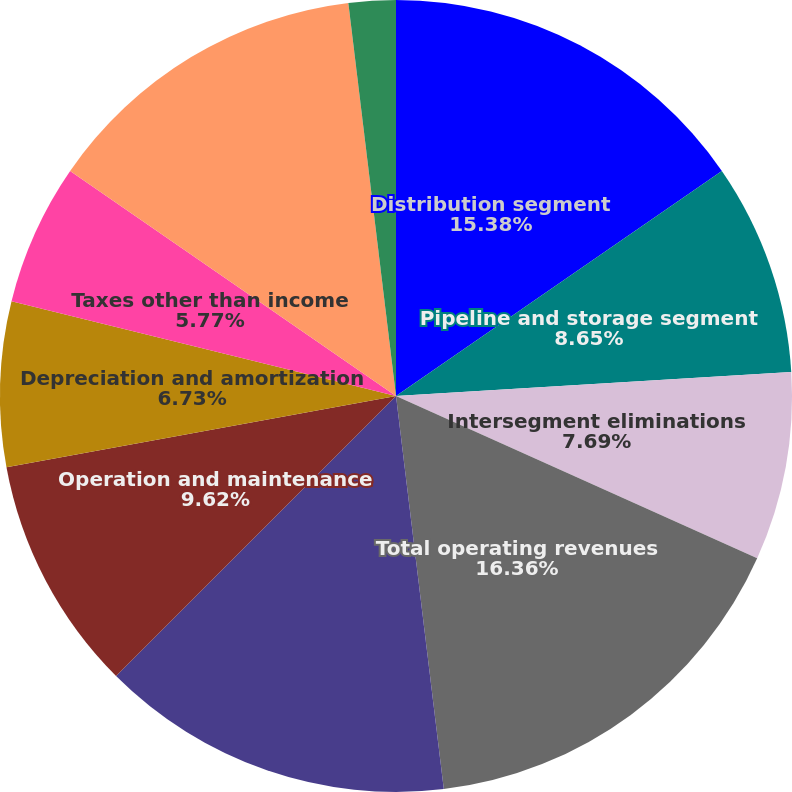<chart> <loc_0><loc_0><loc_500><loc_500><pie_chart><fcel>Distribution segment<fcel>Pipeline and storage segment<fcel>Intersegment eliminations<fcel>Total operating revenues<fcel>Total purchased gas cost<fcel>Operation and maintenance<fcel>Depreciation and amortization<fcel>Taxes other than income<fcel>Operating income<fcel>Miscellaneous expense<nl><fcel>15.38%<fcel>8.65%<fcel>7.69%<fcel>16.35%<fcel>14.42%<fcel>9.62%<fcel>6.73%<fcel>5.77%<fcel>13.46%<fcel>1.92%<nl></chart> 